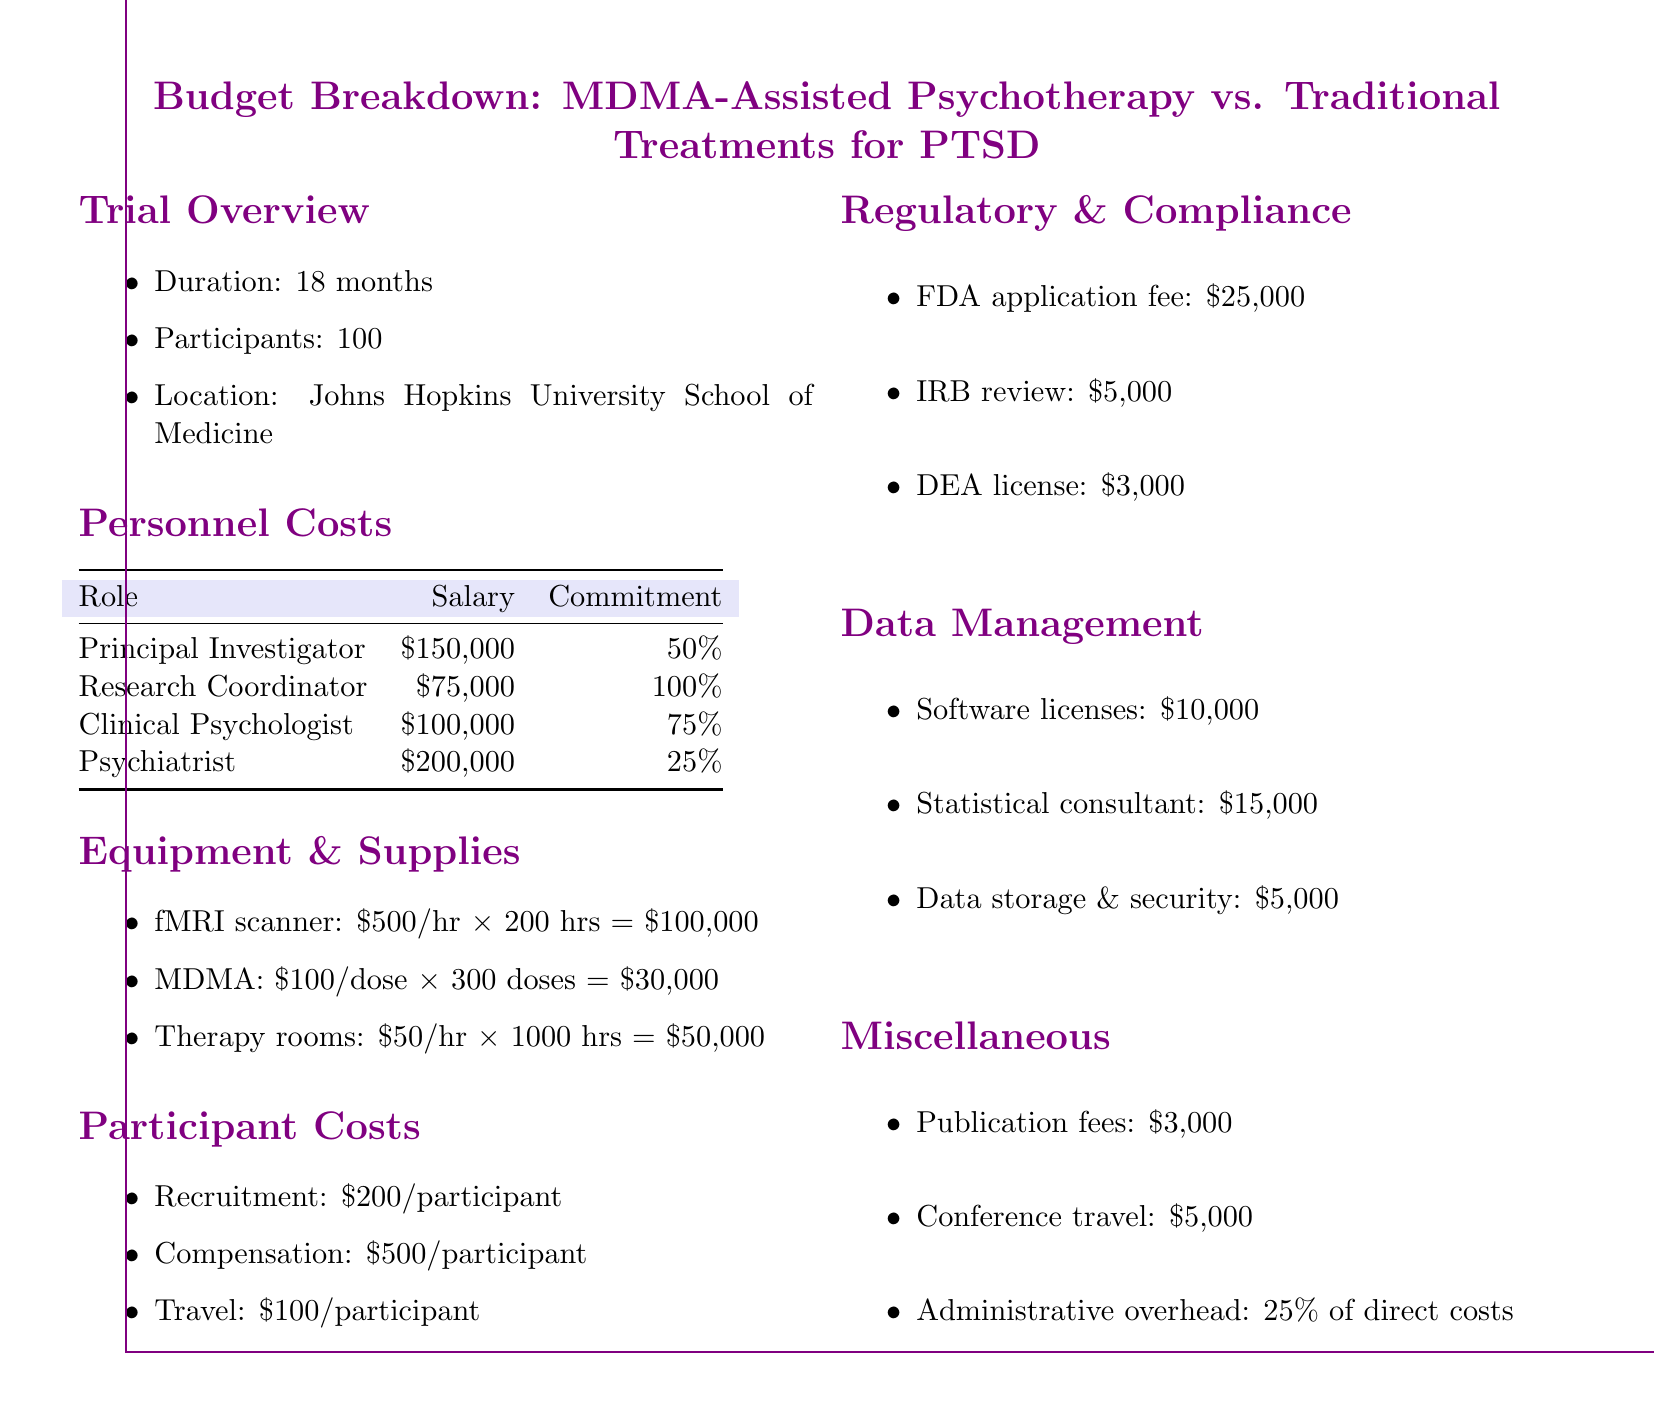What is the duration of the trial? The duration of the trial is explicitly stated in the document as 18 months.
Answer: 18 months How many participants are involved in the trial? The document specifies that there are 100 participants in the study.
Answer: 100 What is the salary of the Principal Investigator? The salary for the Principal Investigator is listed in the personnel costs table as $150,000.
Answer: $150,000 What is the total cost for MDMA? The total cost for MDMA can be calculated from the document: $100 per dose times 300 doses equals $30,000.
Answer: $30,000 What is the total amount allocated for regulatory and compliance costs? The document lists the FDA application fee, IRB review, and DEA license fees, totaling $33,000.
Answer: $33,000 What percentage of direct costs is allocated for administrative overhead? The document states that administrative overhead is 25% of direct costs.
Answer: 25% What is the cost of travel compensation per participant? The document indicates that the travel compensation is $100 per participant.
Answer: $100 Which institution is conducting the trial? The document identifies Johns Hopkins University School of Medicine as the location for the trial.
Answer: Johns Hopkins University School of Medicine How many hours of therapy rooms are budgeted? The budget includes 1000 hours of therapy room usage.
Answer: 1000 hours 